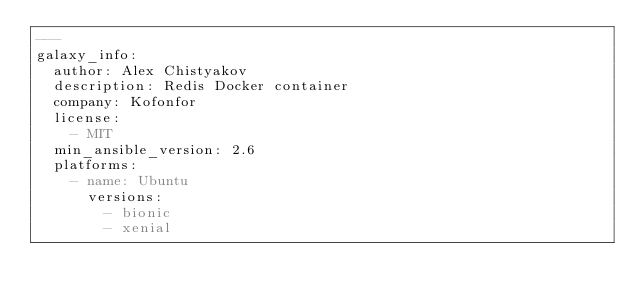Convert code to text. <code><loc_0><loc_0><loc_500><loc_500><_YAML_>---
galaxy_info:
  author: Alex Chistyakov
  description: Redis Docker container
  company: Kofonfor
  license:
    - MIT
  min_ansible_version: 2.6
  platforms:
    - name: Ubuntu
      versions:
        - bionic
        - xenial

</code> 